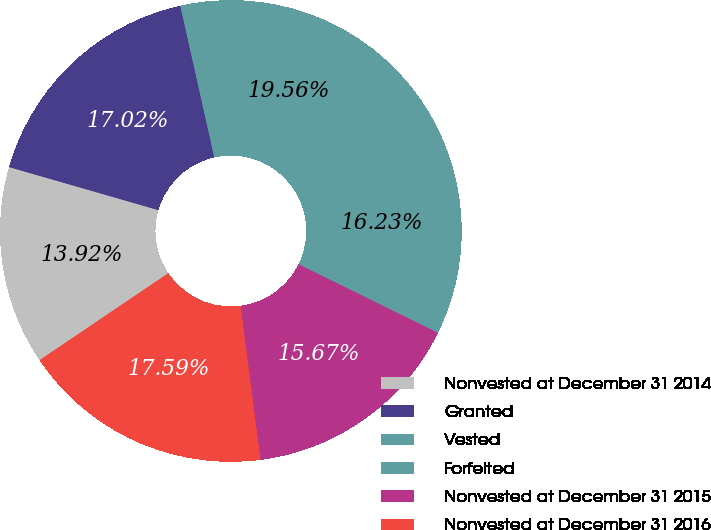<chart> <loc_0><loc_0><loc_500><loc_500><pie_chart><fcel>Nonvested at December 31 2014<fcel>Granted<fcel>Vested<fcel>Forfeited<fcel>Nonvested at December 31 2015<fcel>Nonvested at December 31 2016<nl><fcel>13.92%<fcel>17.02%<fcel>19.56%<fcel>16.23%<fcel>15.67%<fcel>17.59%<nl></chart> 